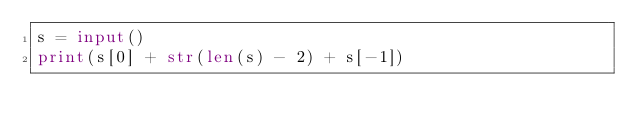Convert code to text. <code><loc_0><loc_0><loc_500><loc_500><_Python_>s = input()
print(s[0] + str(len(s) - 2) + s[-1])</code> 